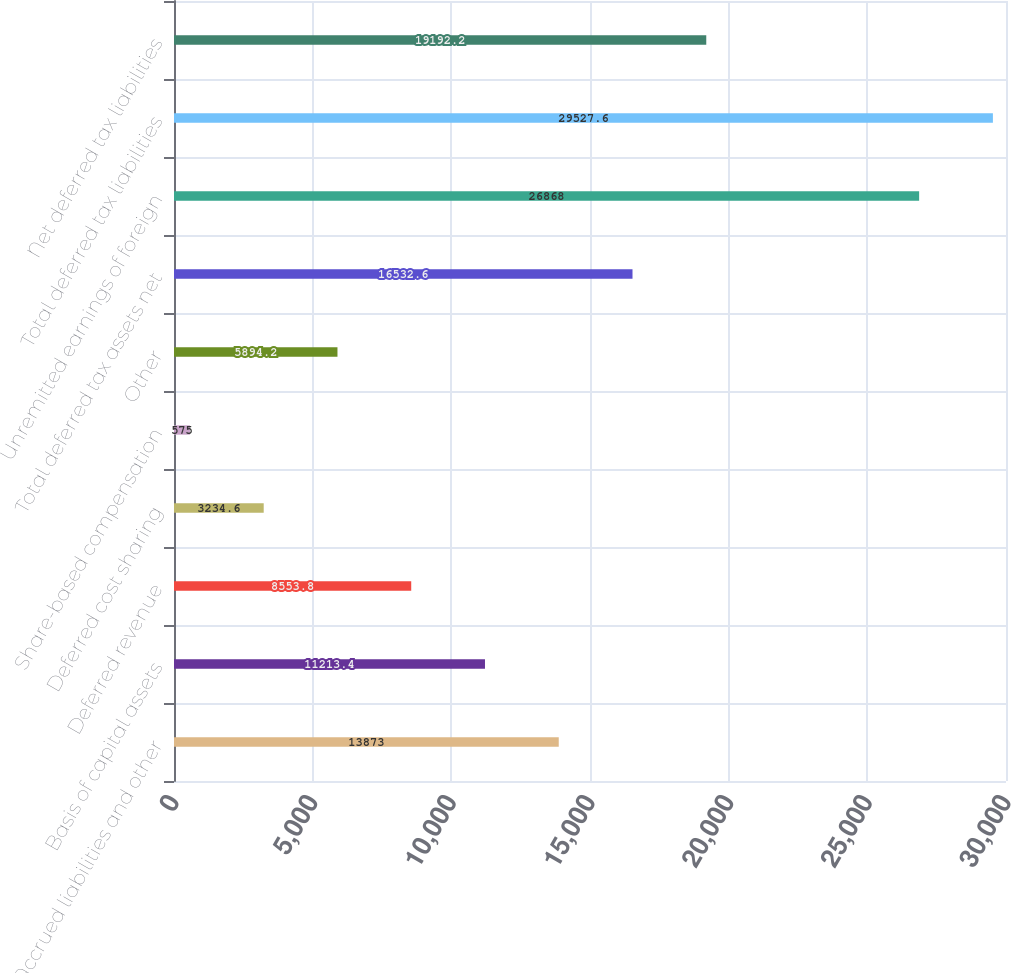Convert chart to OTSL. <chart><loc_0><loc_0><loc_500><loc_500><bar_chart><fcel>Accrued liabilities and other<fcel>Basis of capital assets<fcel>Deferred revenue<fcel>Deferred cost sharing<fcel>Share-based compensation<fcel>Other<fcel>Total deferred tax assets net<fcel>Unremitted earnings of foreign<fcel>Total deferred tax liabilities<fcel>Net deferred tax liabilities<nl><fcel>13873<fcel>11213.4<fcel>8553.8<fcel>3234.6<fcel>575<fcel>5894.2<fcel>16532.6<fcel>26868<fcel>29527.6<fcel>19192.2<nl></chart> 